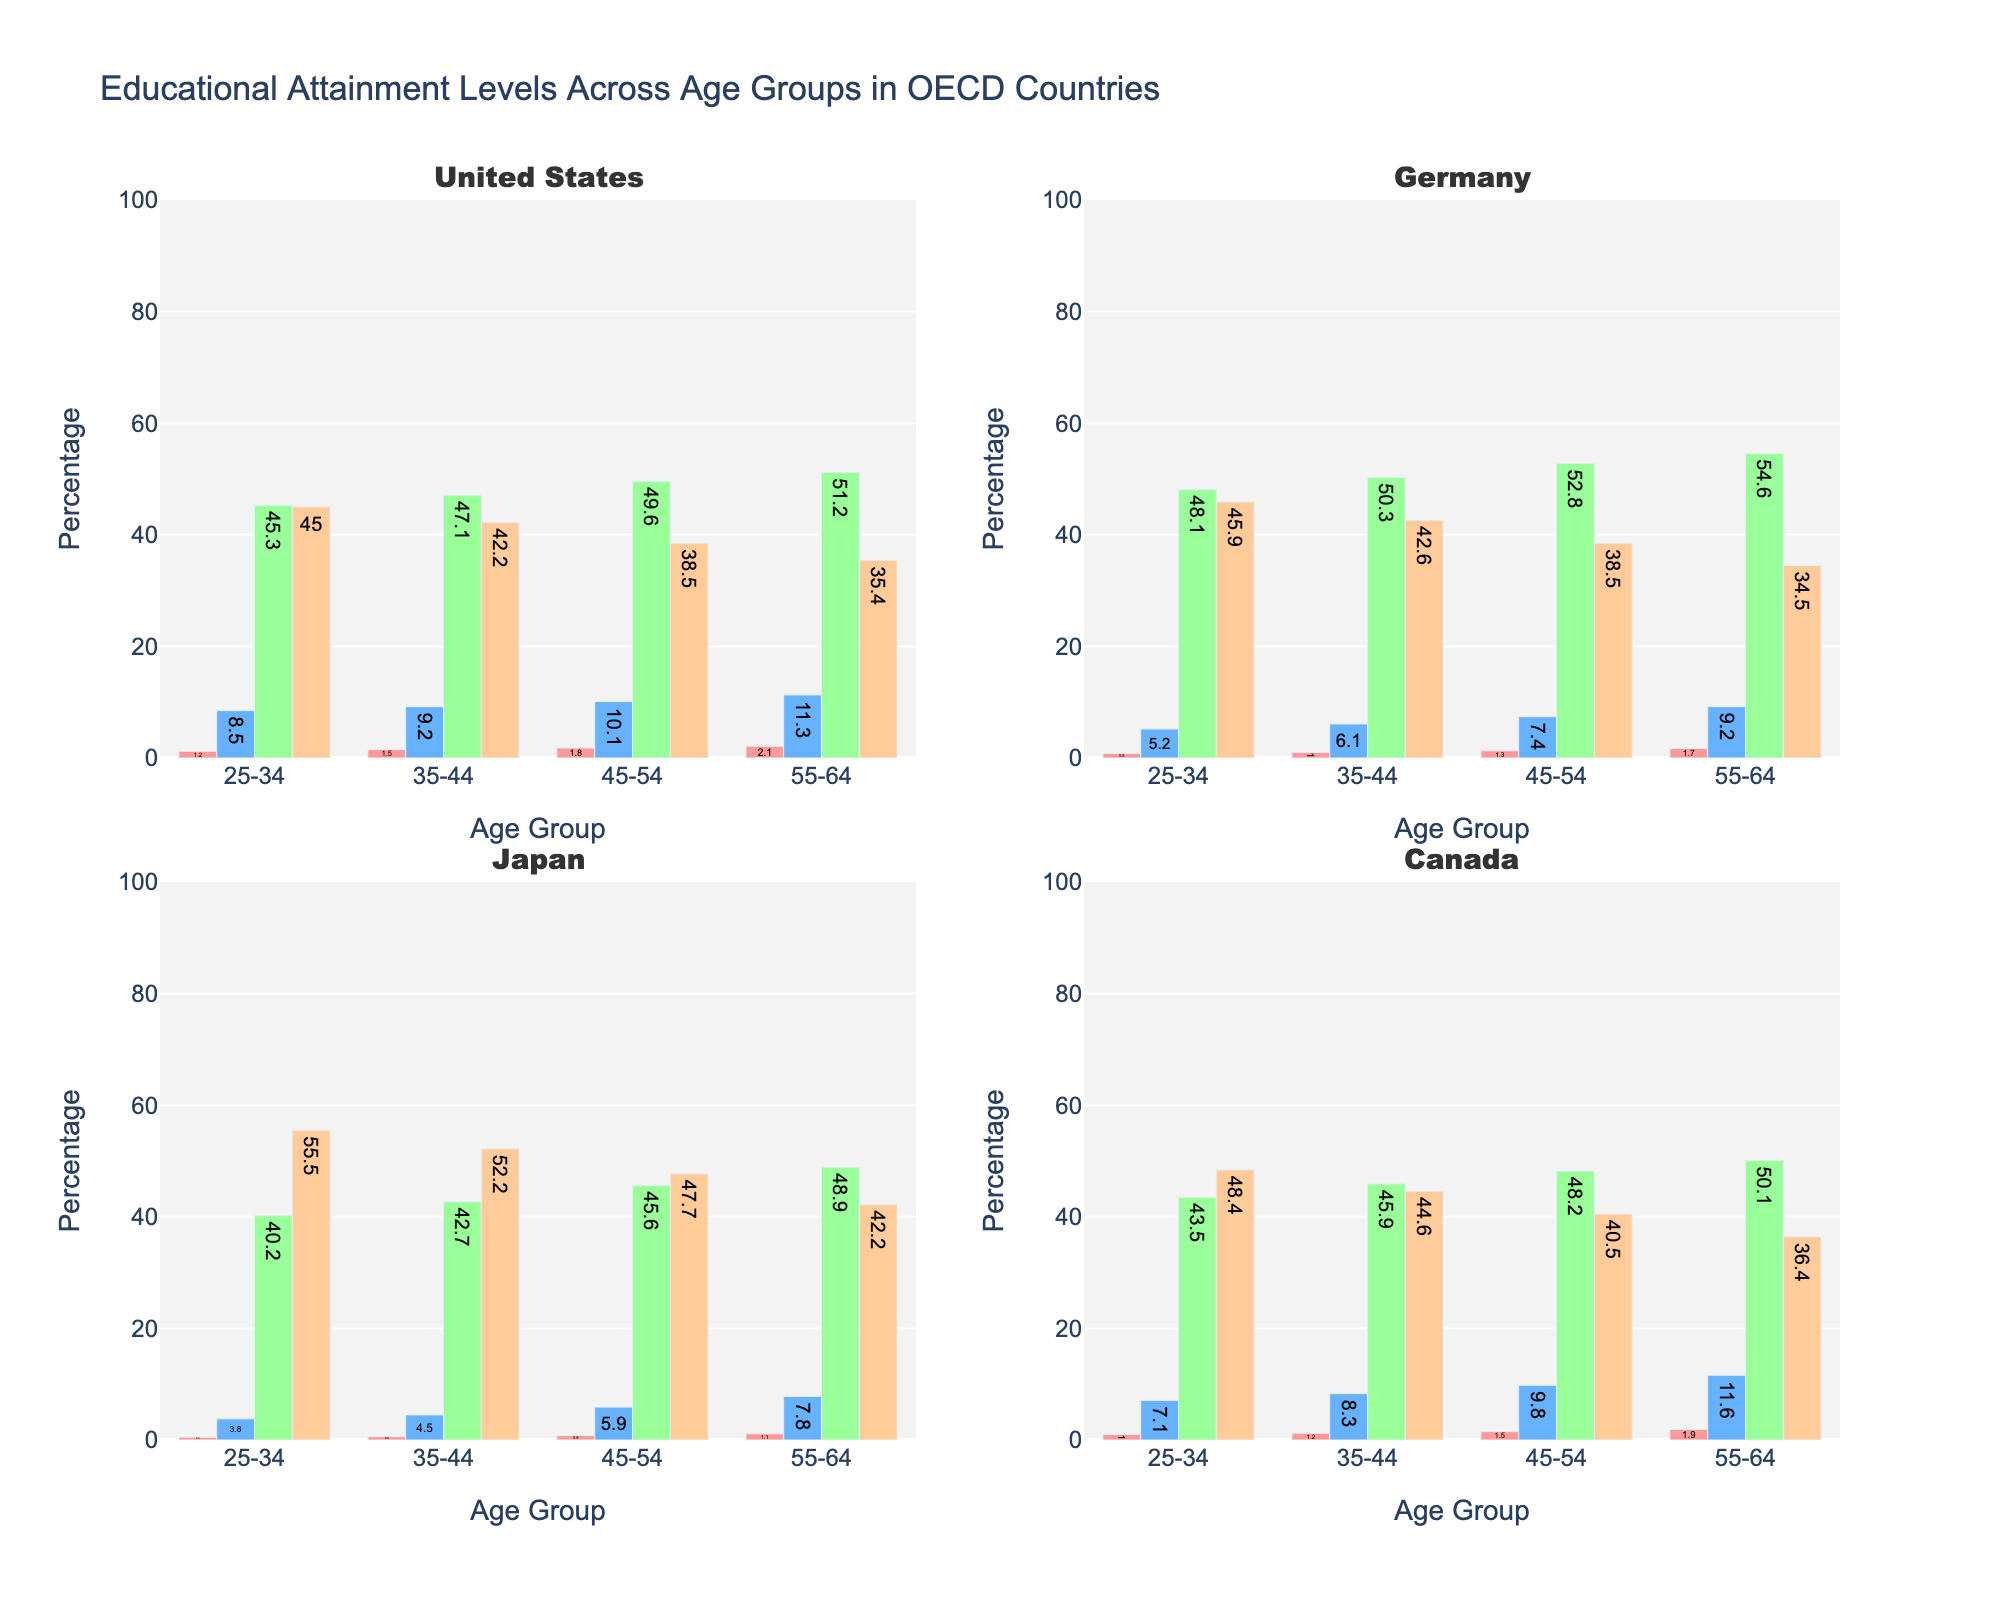what age group has the highest percentage of tertiary education in Japan? Look for the highest value in the "Tertiary" bar for Japan subplot. The 25-34 age group shows the highest percentage of tertiary education at 55.5%.
Answer: 25-34 What is the title of the figure? The title of the figure is displayed at the top of the figure. It reads, "Educational Attainment Levels Across Age Groups in OECD Countries".
Answer: Educational Attainment Levels Across Age Groups in OECD Countries Which educational level has the smallest percentage in the 35-44 age group across all countries? Look at the 35-44 age group for each country and identify the smallest bar across all educational categories. For each country: United States (No Formal Education: 1.5%), Germany (No Formal Education: 1.0%), Japan (No Formal Education: 0.6%), Canada (No Formal Education: 1.2%). The smallest value is 0.6% in Japan.
Answer: No Formal Education in Japan Compare the percentage of secondary education in the 45-54 age group between the United States and Germany. Which country has a higher percentage? Look at the 45-54 age group in the subplots for the United States and Germany. The United States has 49.6% and Germany has 52.8% in Secondary education. Germany has a higher percentage.
Answer: Germany What is the average percentage of primary education in the 25-34 age group across all countries? Calculate the average by summing the primary education percentages for the 25-34 age group in each country and then dividing by the number of countries: (8.5 + 5.2 + 3.8 + 7.1)/4 = 24.6/4 = 6.15%.
Answer: 6.15% How does the percentage of tertiary education in the 55-64 age group in Canada compare to that in the United States? Look at the 55-64 age group for both countries and compare the "Tertiary" bars. The United States shows 35.4% and Canada shows 36.4%, so Canada has a slightly higher percentage.
Answer: Canada has a slightly higher percentage Does the percentage of individuals with no formal education increase or decrease with age in Germany? Look at the "No Formal Education" bars for Germany across all age groups. We see values increasing from 0.8% (25-34) to 1.0% (35-44) to 1.3% (45-54) to 1.7% (55-64).
Answer: Increase Which country has the highest percentage of individuals with secondary education in the 25-34 age group? Compare the "Secondary" bars for the 25-34 age group across all four subplots. Germany has the highest percentage at 48.1%.
Answer: Germany What is the difference in the percentage of tertiary education between the 35-44 and 55-64 age groups in Japan? Subtract the percentage of tertiary education in the 55-64 age group from that in the 35-44 age group for Japan: 52.2% - 42.2% = 10%.
Answer: 10% Which age group in Canada has the highest combined percentage for secondary and tertiary education? Add the percentages of secondary and tertiary education for each age group in Canada: 25-34: 43.5 + 48.4 = 91.9, 35-44: 45.9 + 44.6 = 90.5, 45-54: 48.2 + 40.5 = 88.7, 55-64: 50.1 + 36.4 = 86.5. The 25-34 age group has the highest combined percentage at 91.9%.
Answer: 25-34 